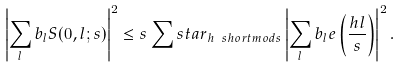<formula> <loc_0><loc_0><loc_500><loc_500>\left | \sum _ { l } b _ { l } S ( 0 , l ; s ) \right | ^ { 2 } \leq s \sum s t a r _ { h \ s h o r t m o d { s } } \left | \sum _ { l } b _ { l } e \left ( \frac { h l } { s } \right ) \right | ^ { 2 } .</formula> 